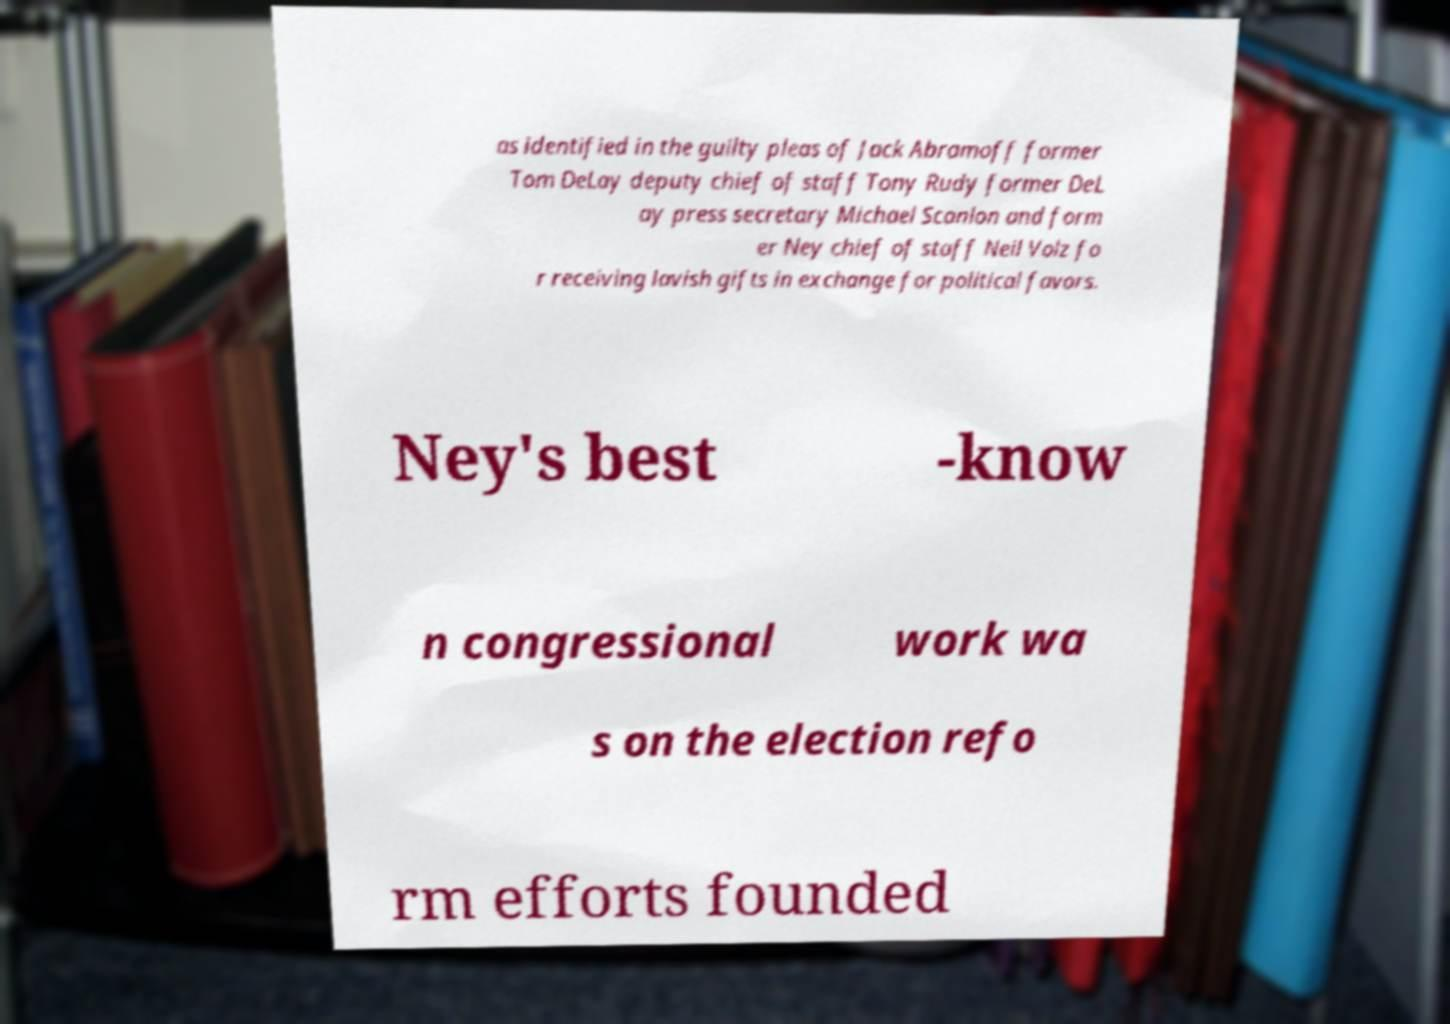Could you extract and type out the text from this image? as identified in the guilty pleas of Jack Abramoff former Tom DeLay deputy chief of staff Tony Rudy former DeL ay press secretary Michael Scanlon and form er Ney chief of staff Neil Volz fo r receiving lavish gifts in exchange for political favors. Ney's best -know n congressional work wa s on the election refo rm efforts founded 